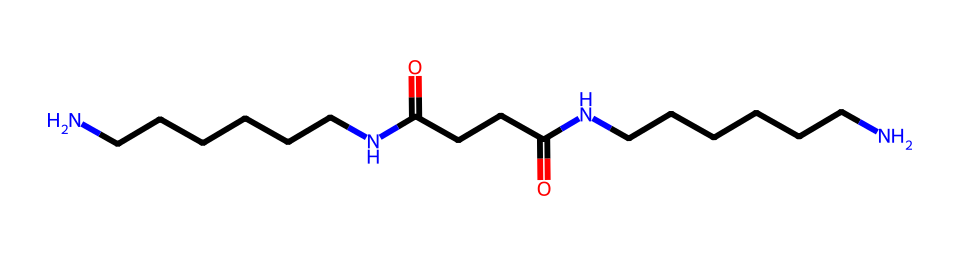What is the molecular formula of this nylon structure? The SMILES representation indicates that the structure contains multiple carbon (C), nitrogen (N), and oxygen (O) atoms. By counting the atoms in the structure, we find that there are 18 carbon atoms, 4 oxygen atoms, and 4 nitrogen atoms, leading us to the molecular formula C18H36N4O4.
Answer: C18H36N4O4 How many nitrogen atoms are present in this molecule? In the provided SMILES, 'N' indicates the presence of nitrogen atoms in the structure. Counting the occurrences, there are four nitrogen atoms present in the structure.
Answer: 4 What type of polymer is represented by this chemical? The molecule consists of repeating units that contain amine linkages (N), which is characteristic of polyamides. This leads us to classify this molecule as a type of polyamide, specifically a form of nylon.
Answer: polyamide Does this nylon have any functional groups? By examining the structure, we can identify carbonyl (C=O) groups as present in the amide linkages (due to the nitrogen bonded to carbon). This indicates that the functional groups are amides.
Answer: amides Is this nylon likely to be stretchy or rigid? The presence of long hydrocarbon chains along with bulky groups suggests that this nylon can exhibit elasticity. However, because it is a synthetic polymer, it tends toward rigidity but may have some flexibility depending on its processing.
Answer: somewhat elastic What is the main chain composition in this nylon structure? The main chain is composed of carbon atoms linked by single (C-C) and double (C=O) bonds leading through the amide linkages. This results in a backbone primarily made up of aliphatic hydrocarbon chains with nitrogen, indicating a polyamide structure.
Answer: aliphatic hydrocarbon chain 